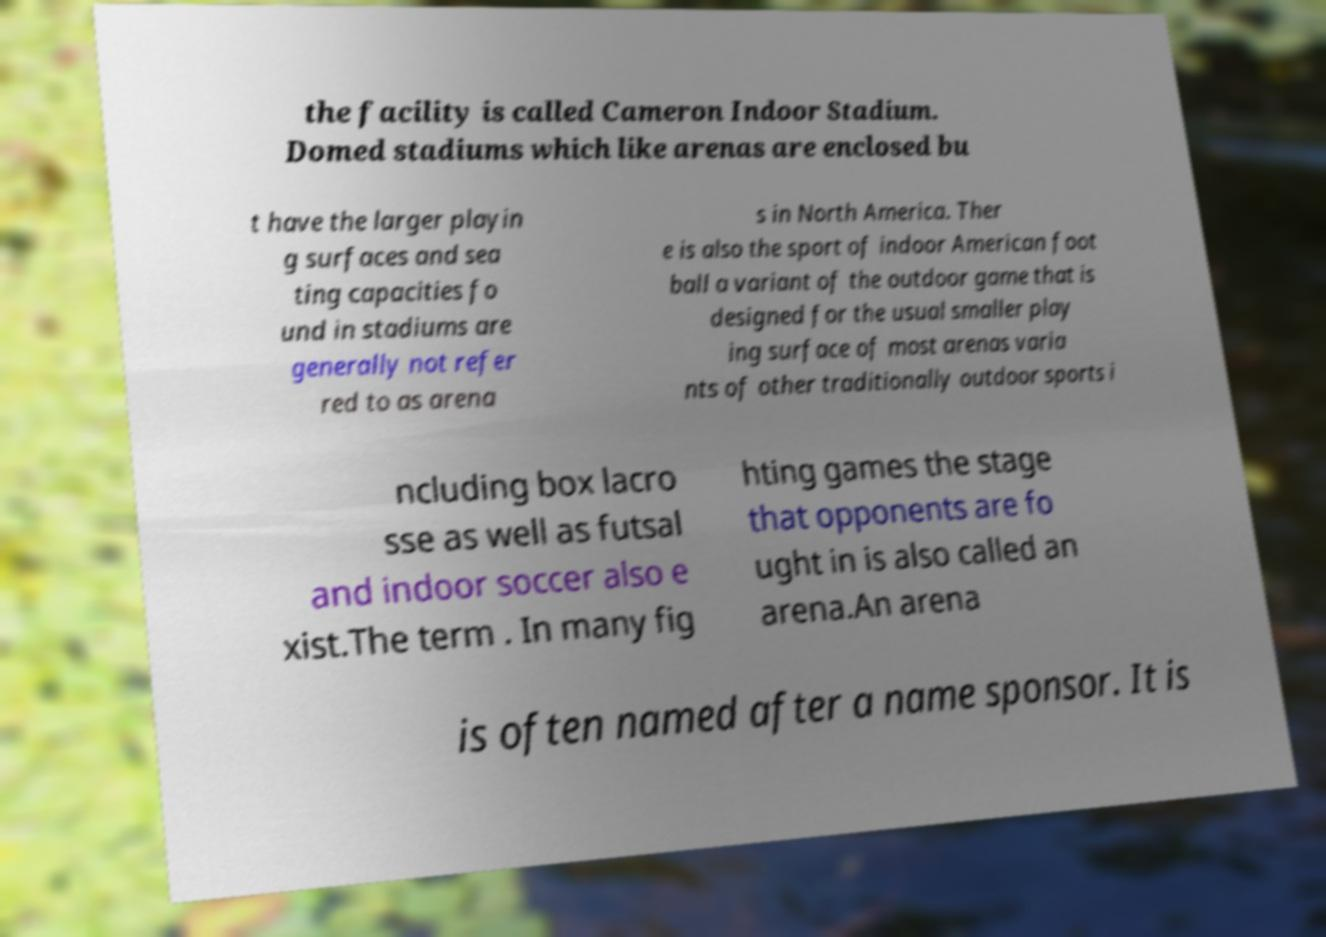Could you assist in decoding the text presented in this image and type it out clearly? the facility is called Cameron Indoor Stadium. Domed stadiums which like arenas are enclosed bu t have the larger playin g surfaces and sea ting capacities fo und in stadiums are generally not refer red to as arena s in North America. Ther e is also the sport of indoor American foot ball a variant of the outdoor game that is designed for the usual smaller play ing surface of most arenas varia nts of other traditionally outdoor sports i ncluding box lacro sse as well as futsal and indoor soccer also e xist.The term . In many fig hting games the stage that opponents are fo ught in is also called an arena.An arena is often named after a name sponsor. It is 